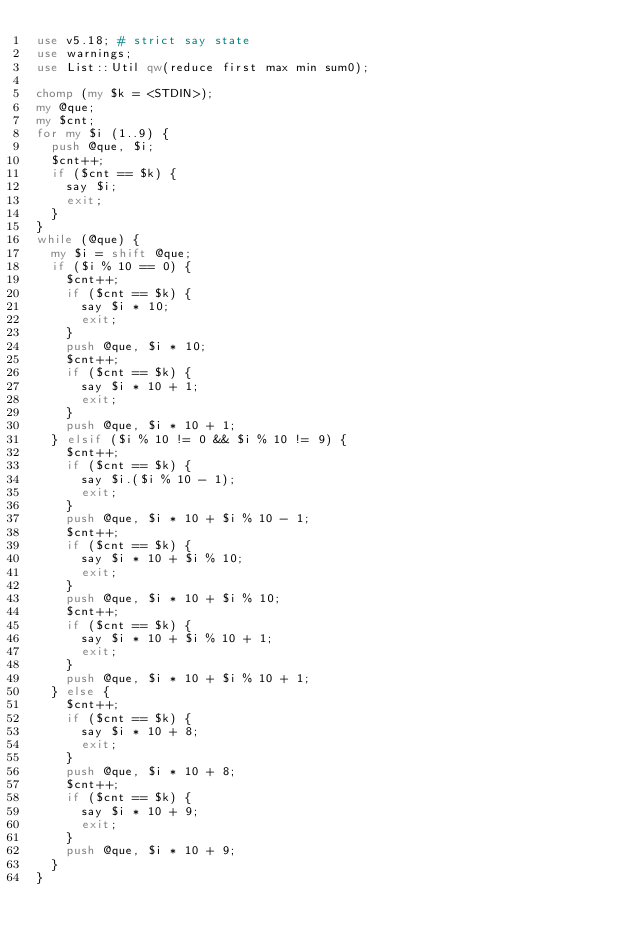<code> <loc_0><loc_0><loc_500><loc_500><_Perl_>use v5.18; # strict say state
use warnings;
use List::Util qw(reduce first max min sum0);

chomp (my $k = <STDIN>);
my @que;
my $cnt;
for my $i (1..9) {
  push @que, $i;
  $cnt++;
  if ($cnt == $k) {
    say $i;
    exit;
  }
}
while (@que) {
  my $i = shift @que;
  if ($i % 10 == 0) {
    $cnt++;
    if ($cnt == $k) {
      say $i * 10;
      exit;
    }
    push @que, $i * 10;
    $cnt++;
    if ($cnt == $k) {
      say $i * 10 + 1;
      exit;
    }
    push @que, $i * 10 + 1;
  } elsif ($i % 10 != 0 && $i % 10 != 9) {
    $cnt++;
    if ($cnt == $k) {
      say $i.($i % 10 - 1);
      exit;
    }
    push @que, $i * 10 + $i % 10 - 1;
    $cnt++;
    if ($cnt == $k) {
      say $i * 10 + $i % 10;
      exit;
    }
    push @que, $i * 10 + $i % 10;
    $cnt++;
    if ($cnt == $k) {
      say $i * 10 + $i % 10 + 1;
      exit;
    }
    push @que, $i * 10 + $i % 10 + 1;
  } else {
    $cnt++;
    if ($cnt == $k) {
      say $i * 10 + 8;
      exit;
    }
    push @que, $i * 10 + 8;
    $cnt++;
    if ($cnt == $k) {
      say $i * 10 + 9;
      exit;
    }
    push @que, $i * 10 + 9;
  }
}</code> 